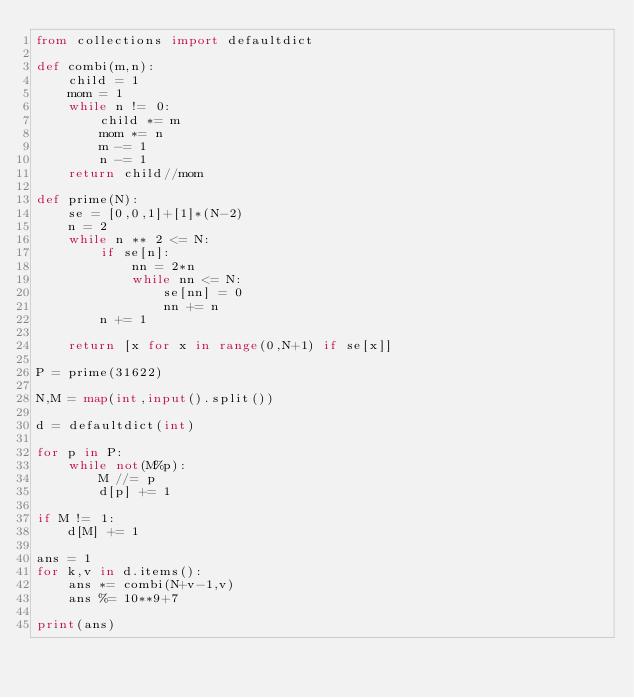<code> <loc_0><loc_0><loc_500><loc_500><_Python_>from collections import defaultdict

def combi(m,n):
    child = 1
    mom = 1
    while n != 0:
        child *= m
        mom *= n
        m -= 1
        n -= 1
    return child//mom

def prime(N):
    se = [0,0,1]+[1]*(N-2)
    n = 2
    while n ** 2 <= N:
        if se[n]:
            nn = 2*n
            while nn <= N:
                se[nn] = 0
                nn += n
        n += 1

    return [x for x in range(0,N+1) if se[x]]

P = prime(31622)

N,M = map(int,input().split())

d = defaultdict(int)

for p in P:
    while not(M%p):
        M //= p
        d[p] += 1

if M != 1:
    d[M] += 1

ans = 1
for k,v in d.items():
    ans *= combi(N+v-1,v)
    ans %= 10**9+7

print(ans)</code> 